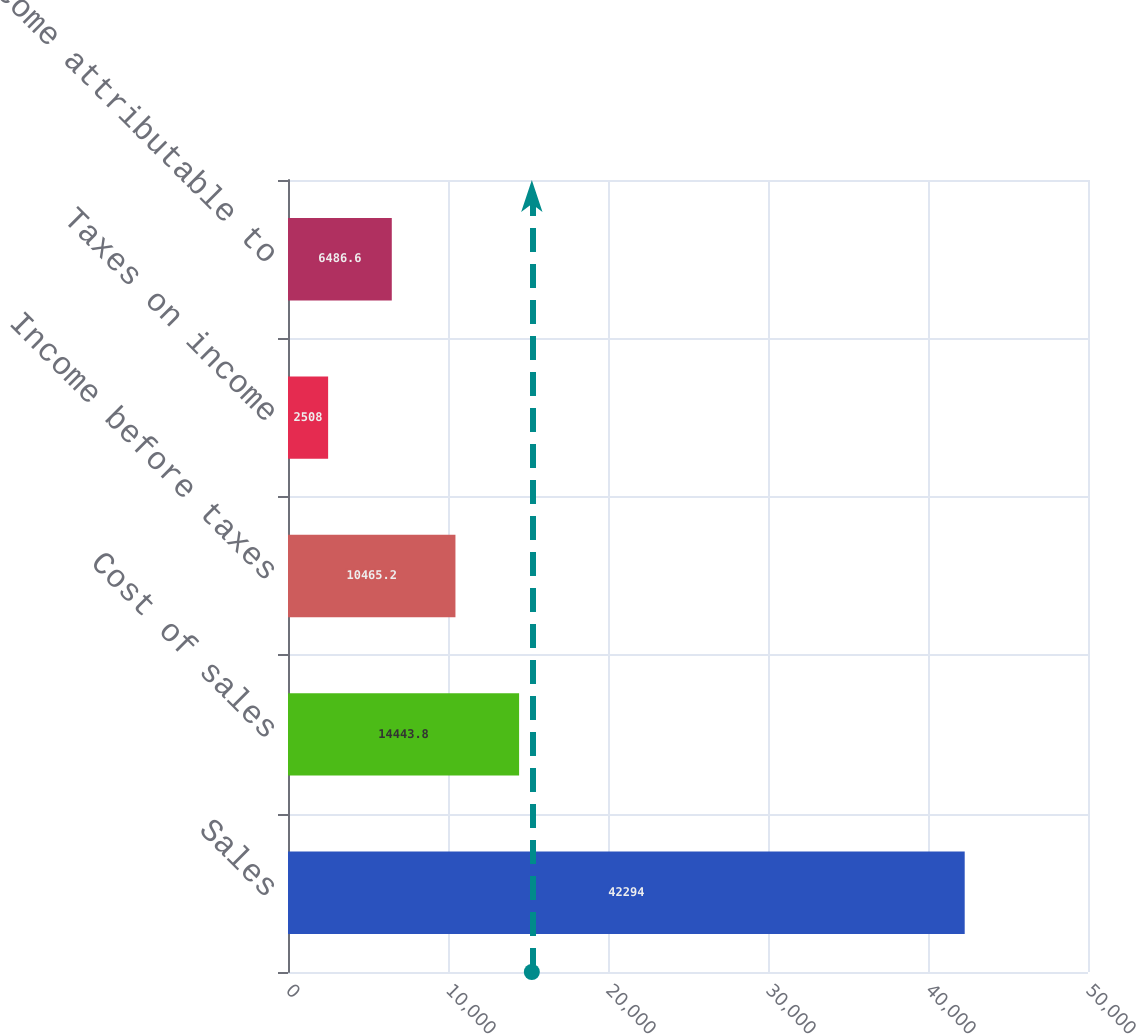Convert chart to OTSL. <chart><loc_0><loc_0><loc_500><loc_500><bar_chart><fcel>Sales<fcel>Cost of sales<fcel>Income before taxes<fcel>Taxes on income<fcel>Net income attributable to<nl><fcel>42294<fcel>14443.8<fcel>10465.2<fcel>2508<fcel>6486.6<nl></chart> 